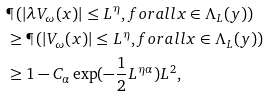Convert formula to latex. <formula><loc_0><loc_0><loc_500><loc_500>& \P \left ( | \lambda V _ { \omega } ( x ) | \leq L ^ { \eta } , f o r a l l x \in \Lambda _ { L } ( y ) \right ) \\ & \geq \P \left ( | V _ { \omega } ( x ) | \leq L ^ { \eta } , f o r a l l x \in \Lambda _ { L } ( y ) \right ) \\ & \geq 1 - C _ { \alpha } \exp ( - \frac { 1 } { 2 } L ^ { \eta \alpha } ) L ^ { 2 } ,</formula> 